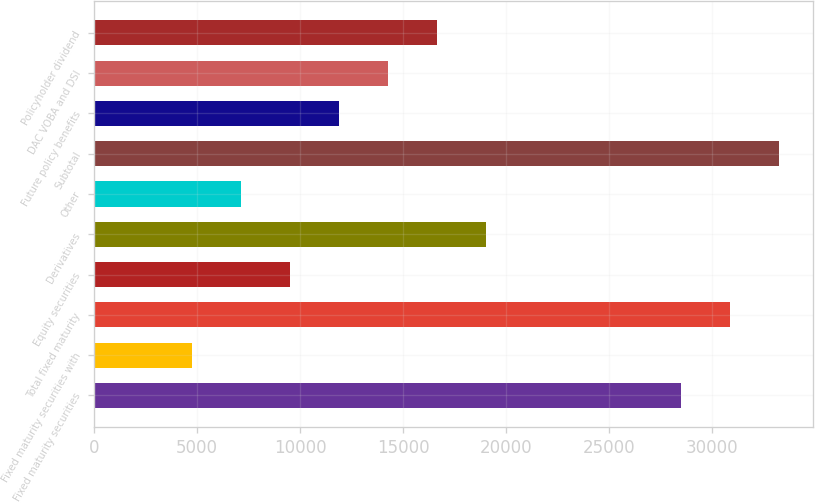Convert chart. <chart><loc_0><loc_0><loc_500><loc_500><bar_chart><fcel>Fixed maturity securities<fcel>Fixed maturity securities with<fcel>Total fixed maturity<fcel>Equity securities<fcel>Derivatives<fcel>Other<fcel>Subtotal<fcel>Future policy benefits<fcel>DAC VOBA and DSI<fcel>Policyholder dividend<nl><fcel>28522.6<fcel>4754.6<fcel>30899.4<fcel>9508.2<fcel>19015.4<fcel>7131.4<fcel>33276.2<fcel>11885<fcel>14261.8<fcel>16638.6<nl></chart> 